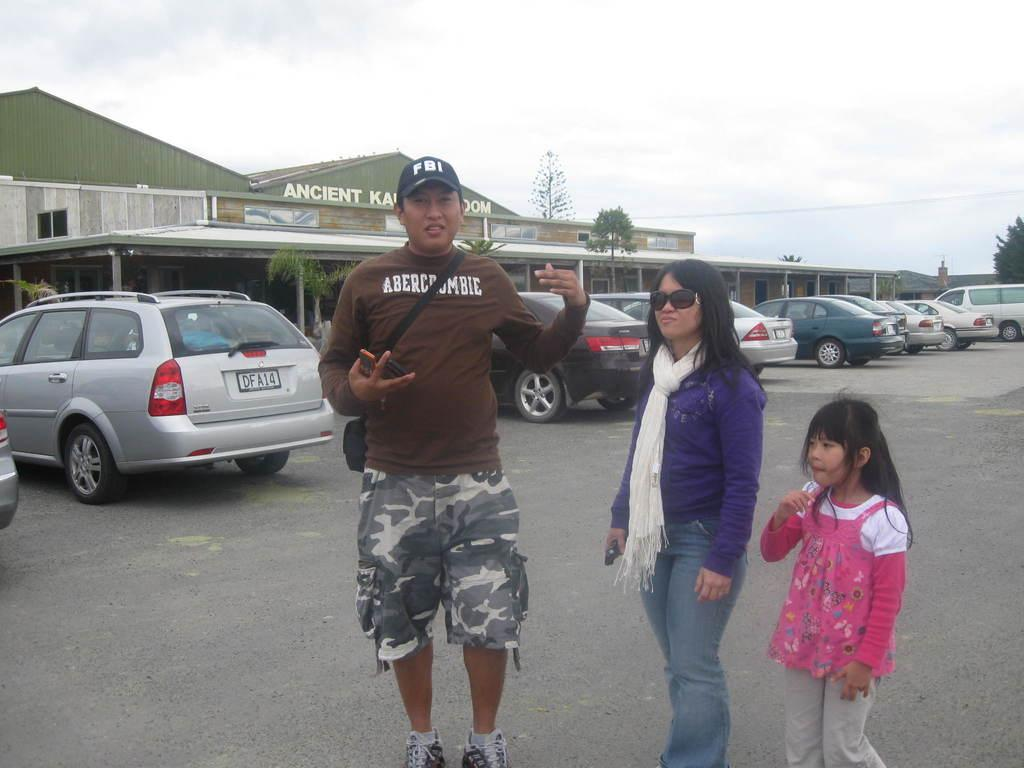How many people are standing on the road in the image? There are three persons standing on the road in the image. What else can be seen in the image besides the people? There are vehicles, sheds, trees, and the sky visible in the image. Can you describe the vehicles in the image? The provided facts do not specify the type or characteristics of the vehicles. What type of vegetation is present in the image? There are trees in the image. What type of cast can be seen on the person's arm in the image? There is no cast visible on any person's arm in the image. What is the person using to carry water in the image? There is no person carrying water or using a pail in the image. 